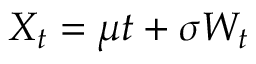Convert formula to latex. <formula><loc_0><loc_0><loc_500><loc_500>X _ { t } = \mu t + \sigma W _ { t }</formula> 